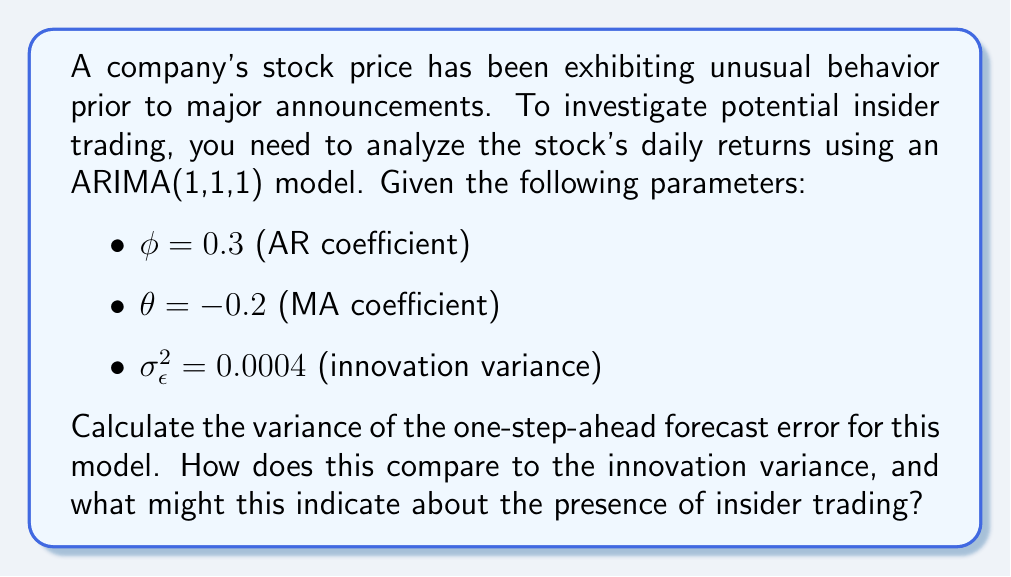Solve this math problem. To calculate the variance of the one-step-ahead forecast error for an ARIMA(1,1,1) model, we follow these steps:

1) The general formula for the variance of the one-step-ahead forecast error in an ARIMA(p,d,q) model is:

   $$\text{Var}(e_t) = \sigma_{\epsilon}^2 (1 + \theta_1^2 + \theta_2^2 + ... + \theta_q^2)$$

2) For our ARIMA(1,1,1) model, we have only one MA coefficient $\theta = -0.2$. Substituting this into the formula:

   $$\text{Var}(e_t) = \sigma_{\epsilon}^2 (1 + \theta^2)$$

3) We're given that $\sigma_{\epsilon}^2 = 0.0004$ and $\theta = -0.2$. Let's substitute these values:

   $$\text{Var}(e_t) = 0.0004 (1 + (-0.2)^2)$$

4) Simplify:
   
   $$\text{Var}(e_t) = 0.0004 (1 + 0.04) = 0.0004 (1.04) = 0.000416$$

5) Compare this to the innovation variance:
   
   $$\frac{\text{Var}(e_t)}{\sigma_{\epsilon}^2} = \frac{0.000416}{0.0004} = 1.04$$

6) Interpretation: The variance of the one-step-ahead forecast error is 4% larger than the innovation variance. This slight increase suggests that there might be some additional volatility in the stock price that isn't captured by the model's normal behavior. 

   In the context of insider trading, this could indicate that there are unusual patterns in the stock's returns just before announcements. While not conclusive evidence, it suggests that further investigation into potential insider trading activities might be warranted.
Answer: $0.000416$; 4% larger than innovation variance, suggesting potential unusual activity. 